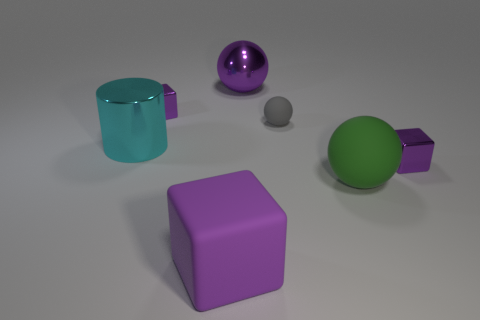How many purple blocks must be subtracted to get 1 purple blocks? 2 Subtract 1 blocks. How many blocks are left? 2 Add 1 large objects. How many objects exist? 8 Subtract all cubes. How many objects are left? 4 Add 5 purple metallic objects. How many purple metallic objects are left? 8 Add 3 big rubber balls. How many big rubber balls exist? 4 Subtract 0 blue cylinders. How many objects are left? 7 Subtract all green things. Subtract all purple metallic blocks. How many objects are left? 4 